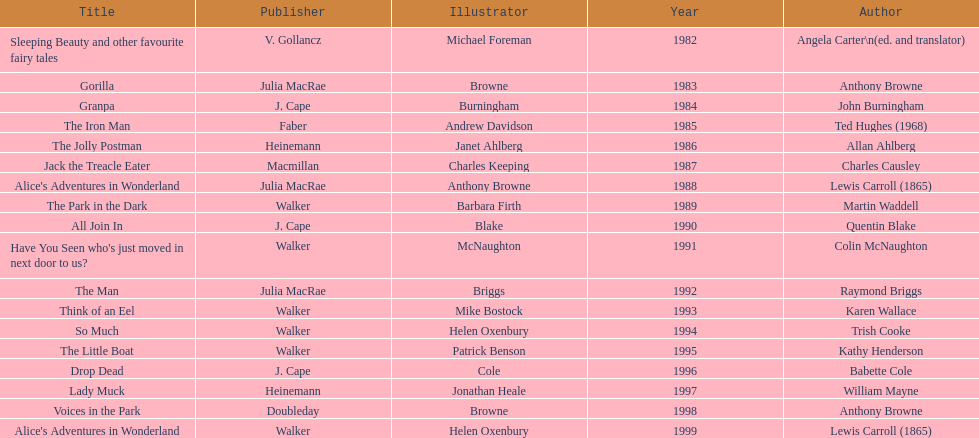Which other author, besides lewis carroll, has won the kurt maschler award twice? Anthony Browne. 